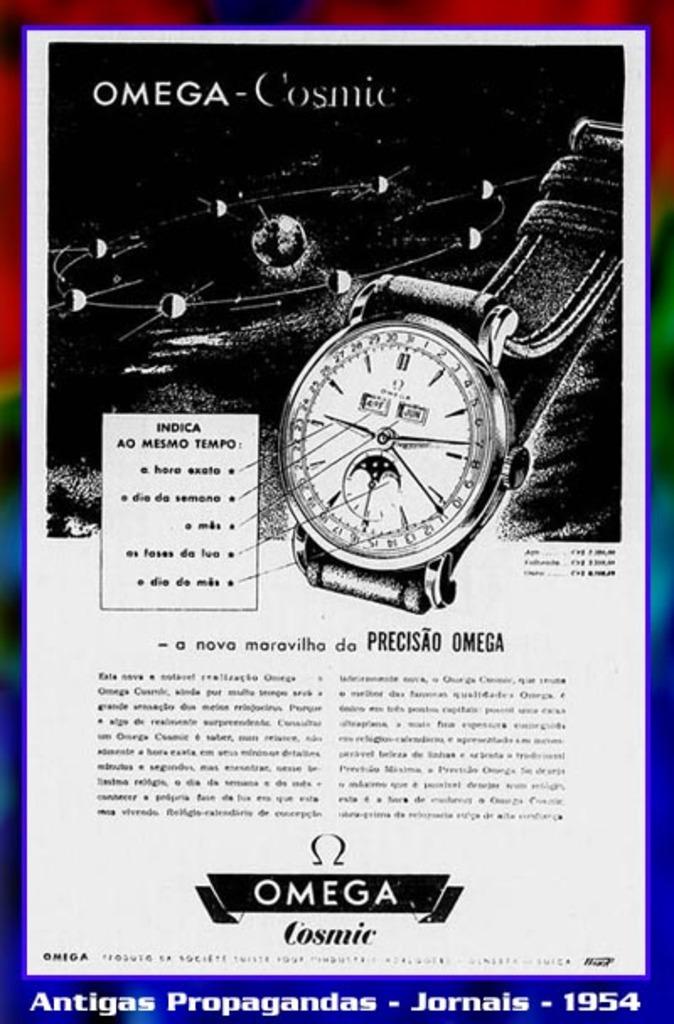What brand of watch is this?
Ensure brevity in your answer.  Omega. This is omega cosmie brand?
Make the answer very short. Yes. 